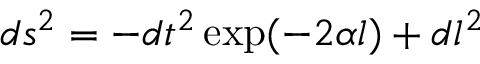<formula> <loc_0><loc_0><loc_500><loc_500>d s ^ { 2 } = - d t ^ { 2 } \exp ( - 2 \alpha l ) + d l ^ { 2 }</formula> 